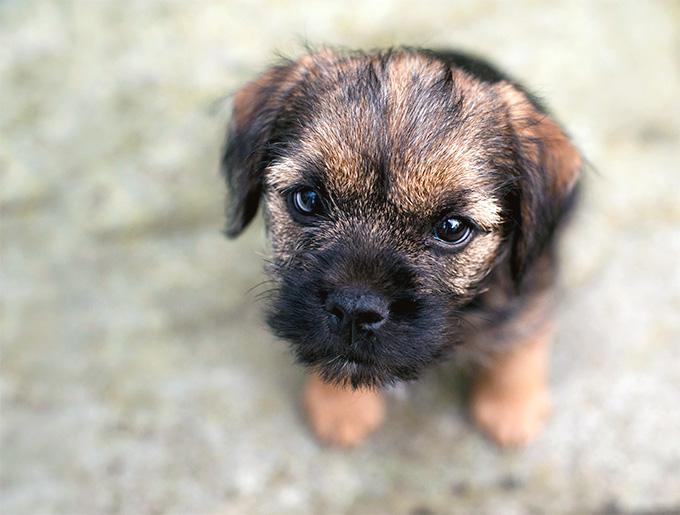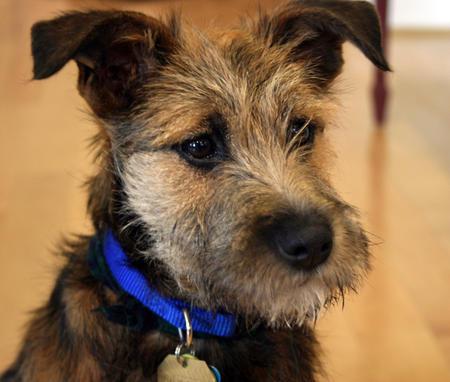The first image is the image on the left, the second image is the image on the right. Analyze the images presented: Is the assertion "The dog on the right has a blue collar" valid? Answer yes or no. Yes. The first image is the image on the left, the second image is the image on the right. For the images shown, is this caption "There is some green grass in the background of every image." true? Answer yes or no. No. 